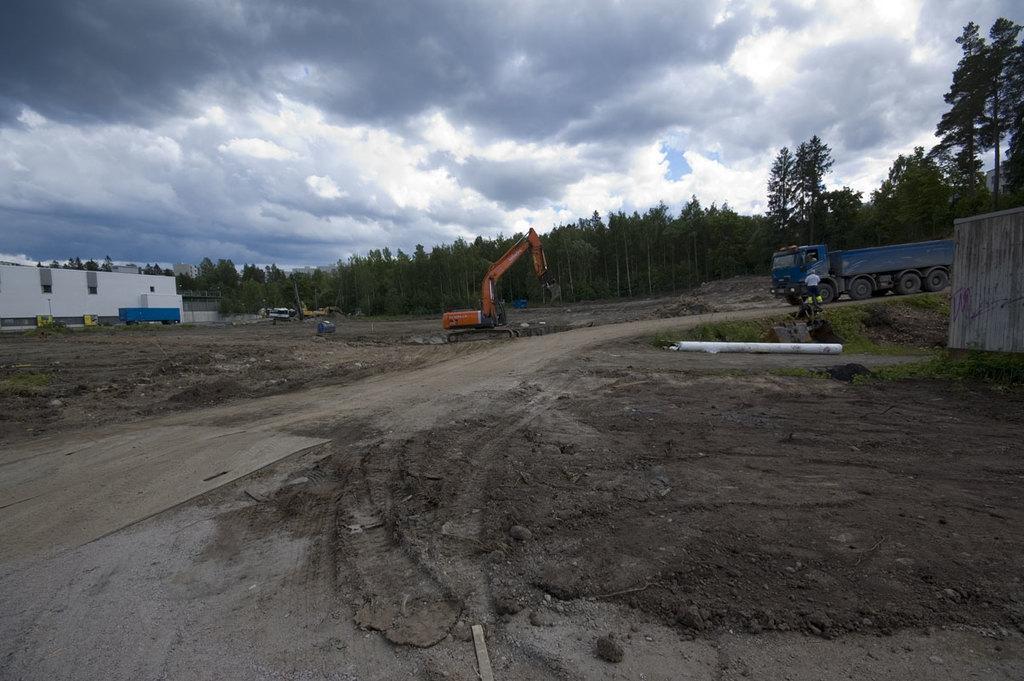How would you summarize this image in a sentence or two? In this picture I can see vehicles. There are buildings and trees, and in the background there is the sky. 